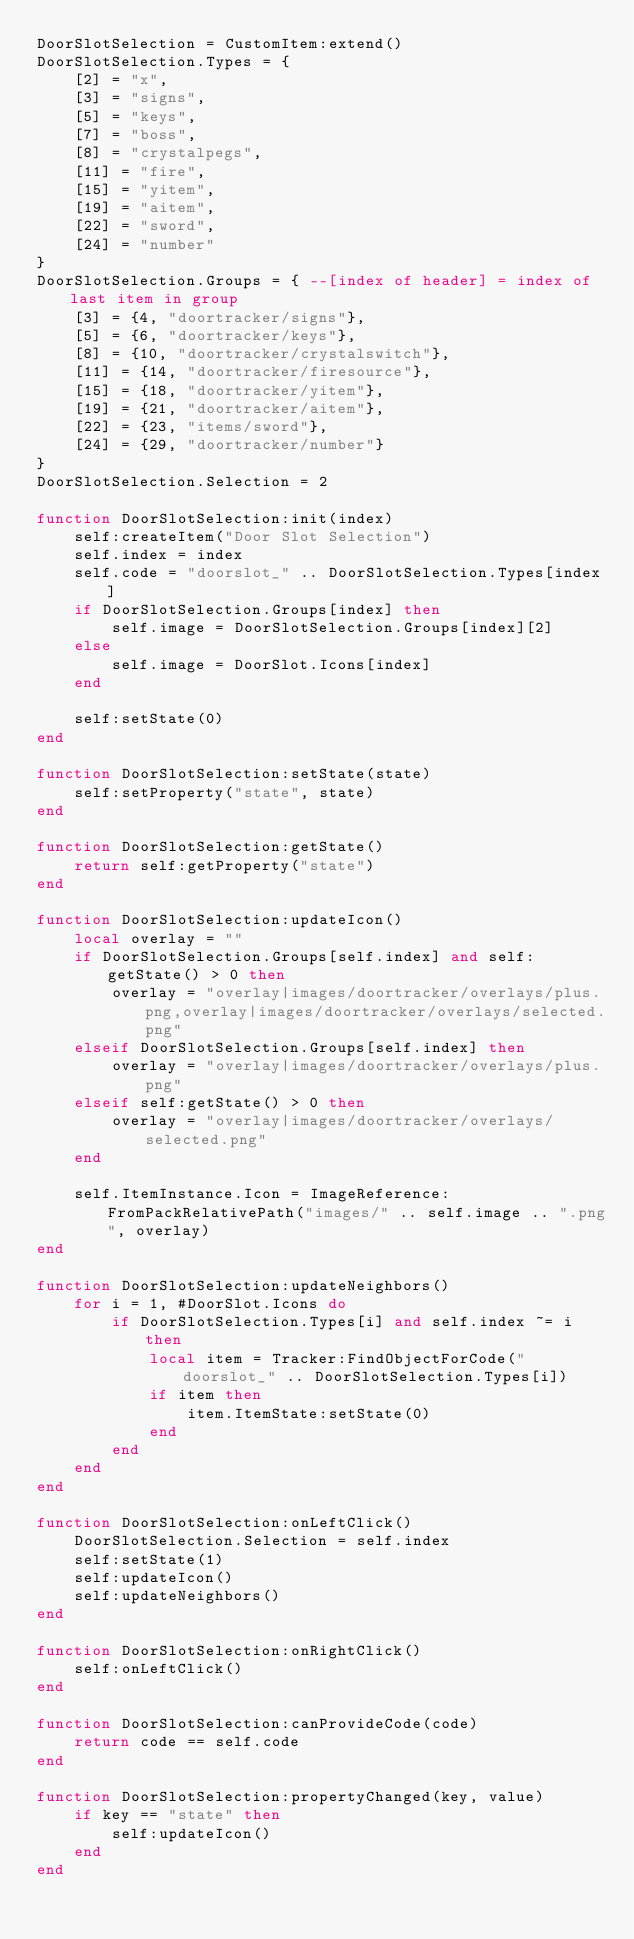<code> <loc_0><loc_0><loc_500><loc_500><_Lua_>DoorSlotSelection = CustomItem:extend()
DoorSlotSelection.Types = {
    [2] = "x",
    [3] = "signs",
    [5] = "keys",
    [7] = "boss",
    [8] = "crystalpegs",
    [11] = "fire",
    [15] = "yitem",
    [19] = "aitem",
    [22] = "sword",
    [24] = "number"
}
DoorSlotSelection.Groups = { --[index of header] = index of last item in group
    [3] = {4, "doortracker/signs"},
    [5] = {6, "doortracker/keys"},
    [8] = {10, "doortracker/crystalswitch"},
    [11] = {14, "doortracker/firesource"},
    [15] = {18, "doortracker/yitem"},
    [19] = {21, "doortracker/aitem"},
    [22] = {23, "items/sword"},
    [24] = {29, "doortracker/number"}
}
DoorSlotSelection.Selection = 2

function DoorSlotSelection:init(index)
    self:createItem("Door Slot Selection")
    self.index = index
    self.code = "doorslot_" .. DoorSlotSelection.Types[index]
    if DoorSlotSelection.Groups[index] then
        self.image = DoorSlotSelection.Groups[index][2]
    else
        self.image = DoorSlot.Icons[index]
    end

    self:setState(0)
end

function DoorSlotSelection:setState(state)
    self:setProperty("state", state)
end

function DoorSlotSelection:getState()
    return self:getProperty("state")
end

function DoorSlotSelection:updateIcon()
    local overlay = ""
    if DoorSlotSelection.Groups[self.index] and self:getState() > 0 then
        overlay = "overlay|images/doortracker/overlays/plus.png,overlay|images/doortracker/overlays/selected.png"
    elseif DoorSlotSelection.Groups[self.index] then
        overlay = "overlay|images/doortracker/overlays/plus.png"
    elseif self:getState() > 0 then
        overlay = "overlay|images/doortracker/overlays/selected.png"
    end

    self.ItemInstance.Icon = ImageReference:FromPackRelativePath("images/" .. self.image .. ".png", overlay)
end

function DoorSlotSelection:updateNeighbors()
    for i = 1, #DoorSlot.Icons do
        if DoorSlotSelection.Types[i] and self.index ~= i then
            local item = Tracker:FindObjectForCode("doorslot_" .. DoorSlotSelection.Types[i])
            if item then
                item.ItemState:setState(0)
            end
        end
    end
end

function DoorSlotSelection:onLeftClick()
    DoorSlotSelection.Selection = self.index
    self:setState(1)
    self:updateIcon()
    self:updateNeighbors()
end

function DoorSlotSelection:onRightClick()
    self:onLeftClick()
end

function DoorSlotSelection:canProvideCode(code)
    return code == self.code
end

function DoorSlotSelection:propertyChanged(key, value)
    if key == "state" then
        self:updateIcon()
    end
end
</code> 